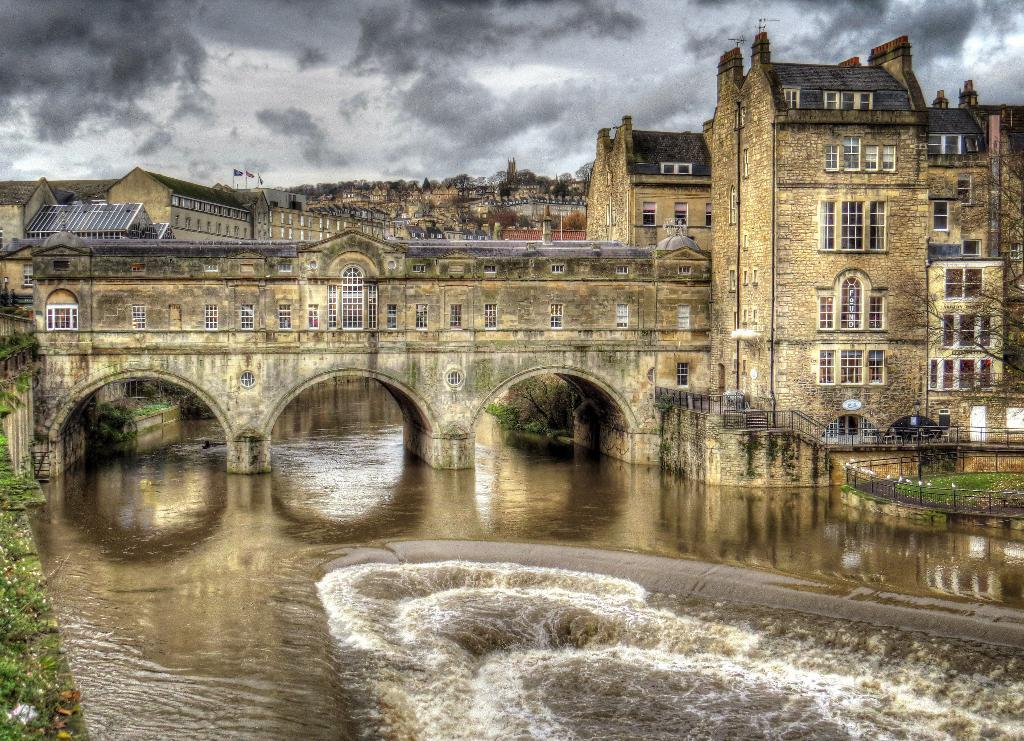What type of structures can be seen in the image? There are buildings in the image. What natural elements are present in the image? There are trees and water visible in the image. What feature connects the two sides of the water? There is a bridge in the image. What can be seen in the background of the image? The sky is visible in the background of the image. What safety feature is present along the bridge? There are railings in the image. Can you tell me how many pots are placed on the side of the bridge in the image? There are no pots present on the side of the bridge in the image. Who can be seen helping people cross the bridge in the image? There is no person depicted in the image providing help to others crossing the bridge. 